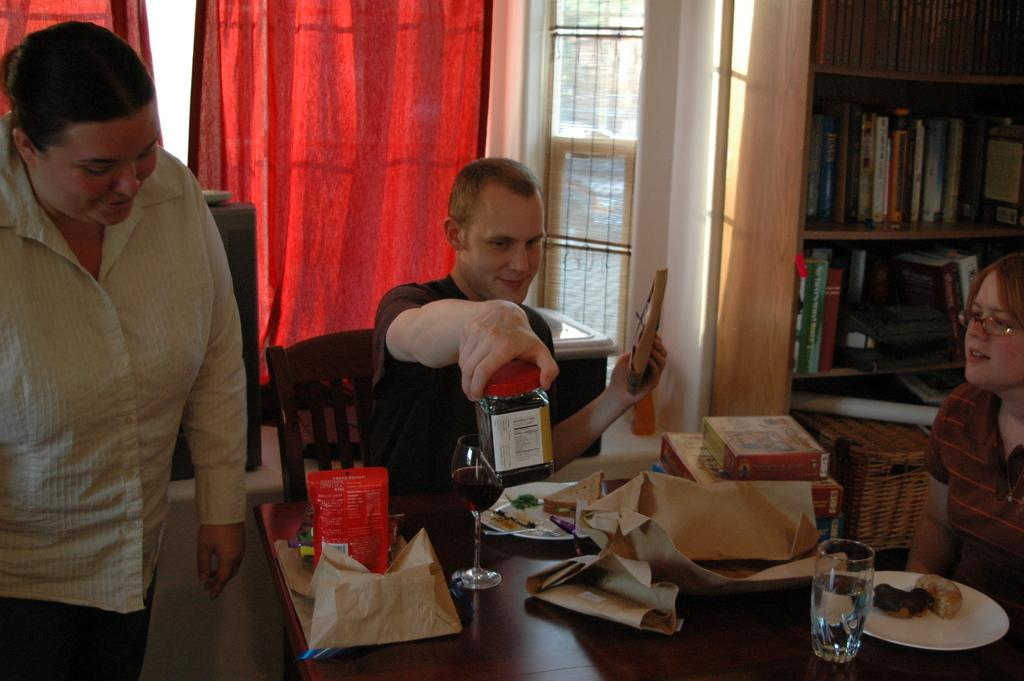What is the gender of the person holding an object in the image? The person holding an object in the image is a man. What is the man holding in the image? The man is holding an object, but the specific object is not mentioned in the facts. How many women are present in the image? There is one woman present in the image. What is the position of the third person in the image? There is another person sitting in the image. What grade does the man receive for his performance in the image? There is no mention of a performance or grade in the image or the provided facts. 